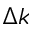Convert formula to latex. <formula><loc_0><loc_0><loc_500><loc_500>\Delta k</formula> 